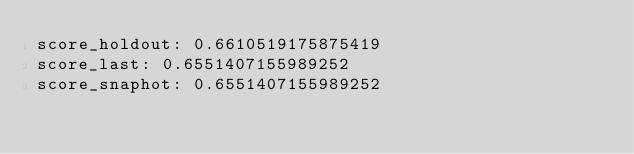Convert code to text. <code><loc_0><loc_0><loc_500><loc_500><_YAML_>score_holdout: 0.6610519175875419
score_last: 0.6551407155989252
score_snaphot: 0.6551407155989252</code> 